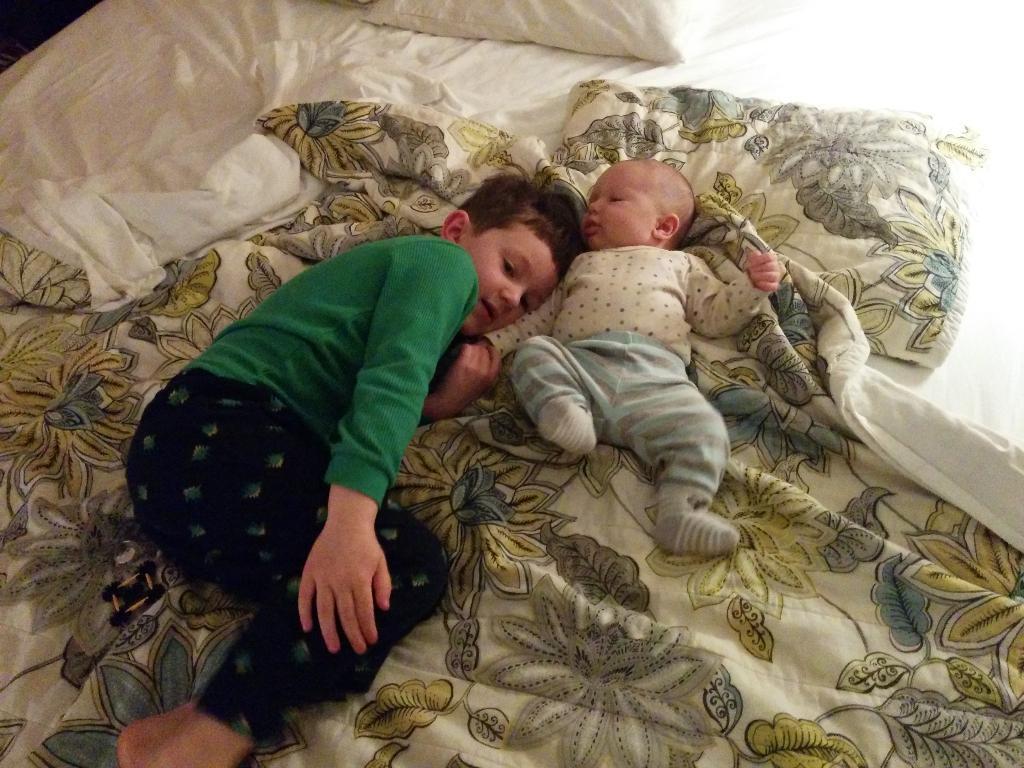How would you summarize this image in a sentence or two? In this picture we can see child and baby sleeping on bed with pillows on it. 